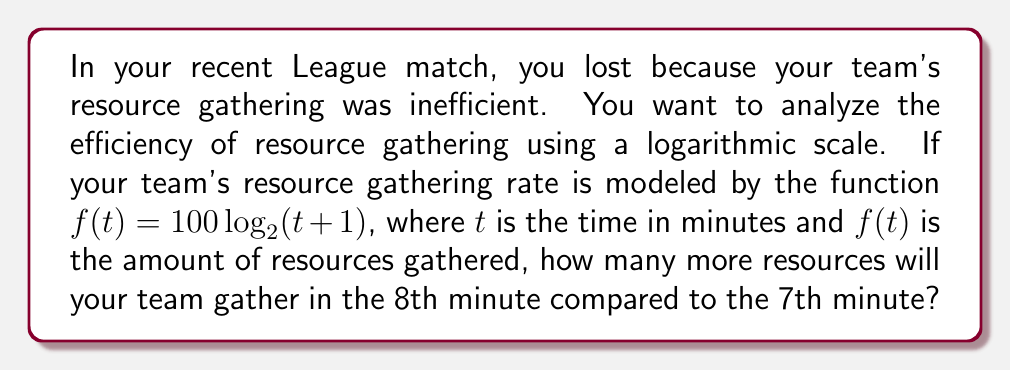Help me with this question. To solve this problem, we need to follow these steps:

1) Calculate the resources gathered at the end of the 7th minute:
   $f(7) = 100 \log_2(7+1) = 100 \log_2(8) = 100 \cdot 3 = 300$ resources

2) Calculate the resources gathered at the end of the 8th minute:
   $f(8) = 100 \log_2(8+1) = 100 \log_2(9) = 100 \cdot \log_2(9)$ resources

3) To calculate $\log_2(9)$, we can use the change of base formula:
   $\log_2(9) = \frac{\ln(9)}{\ln(2)} \approx 3.17$

   So, $f(8) = 100 \cdot 3.17 = 317$ resources

4) The difference in resources gathered is:
   $f(8) - f(7) = 317 - 300 = 17$ resources

This demonstrates how the logarithmic nature of the resource gathering function results in diminishing returns over time, which is common in many game economies.
Answer: The team will gather approximately 17 more resources in the 8th minute compared to the 7th minute. 